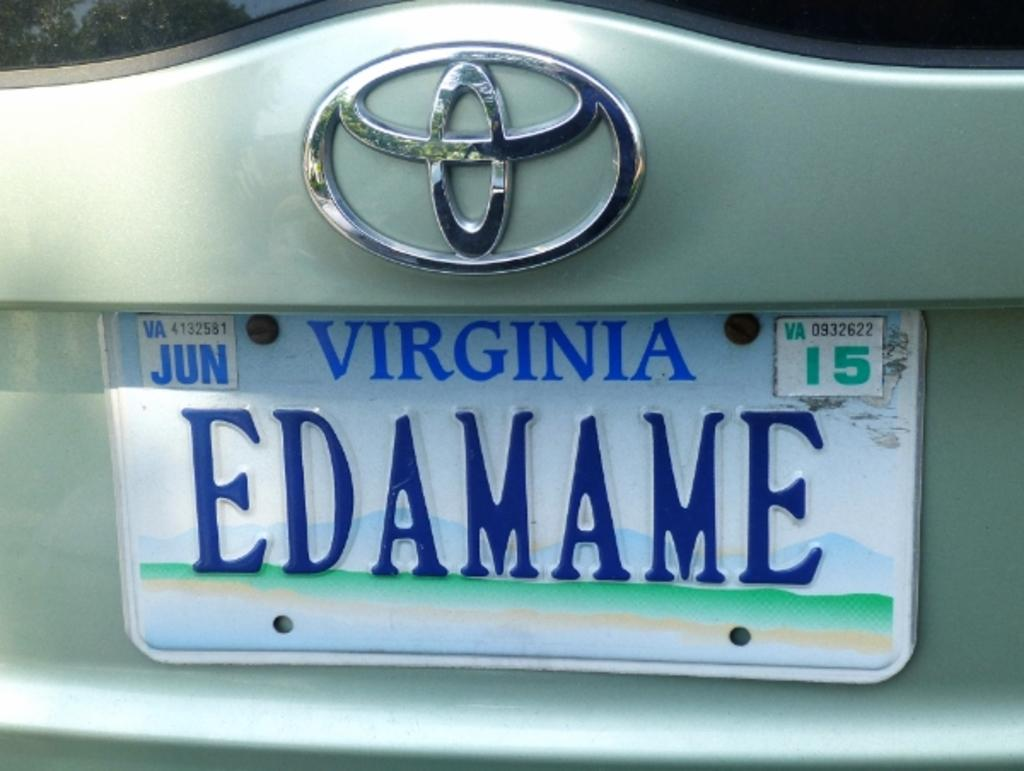<image>
Summarize the visual content of the image. A Virginia license plate that reads EDAMAME expires in June of 2015. 